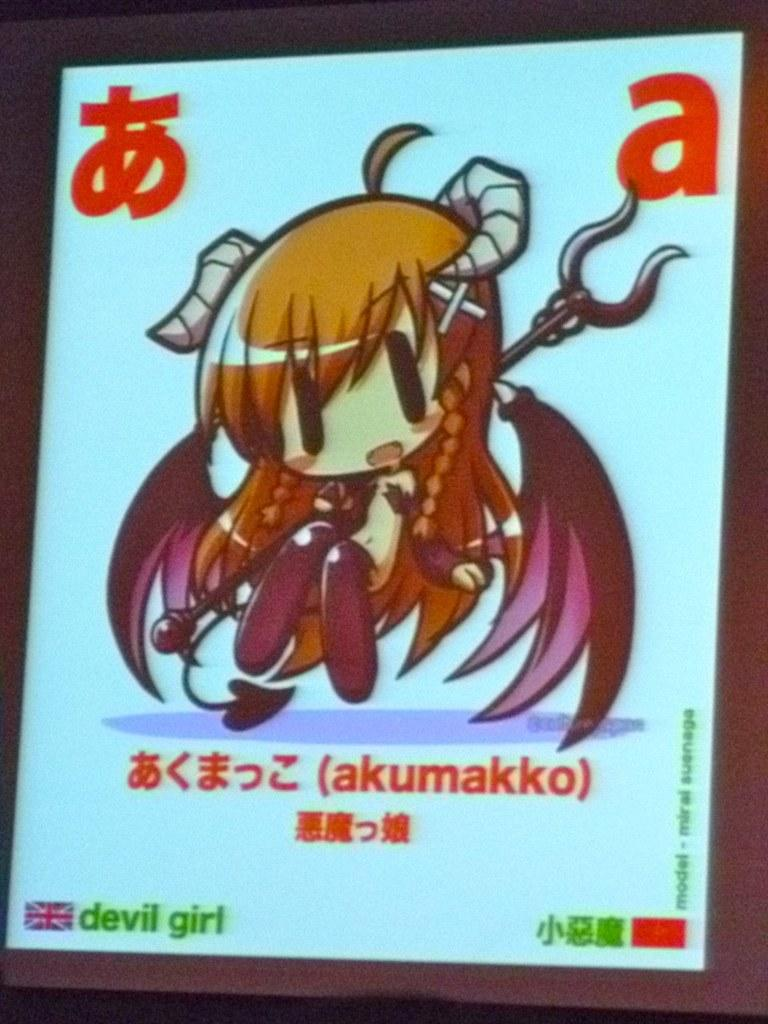<image>
Offer a succinct explanation of the picture presented. The letter a is prominently displayed in the upper right hand corner of the screen, above the cartoon girl. 